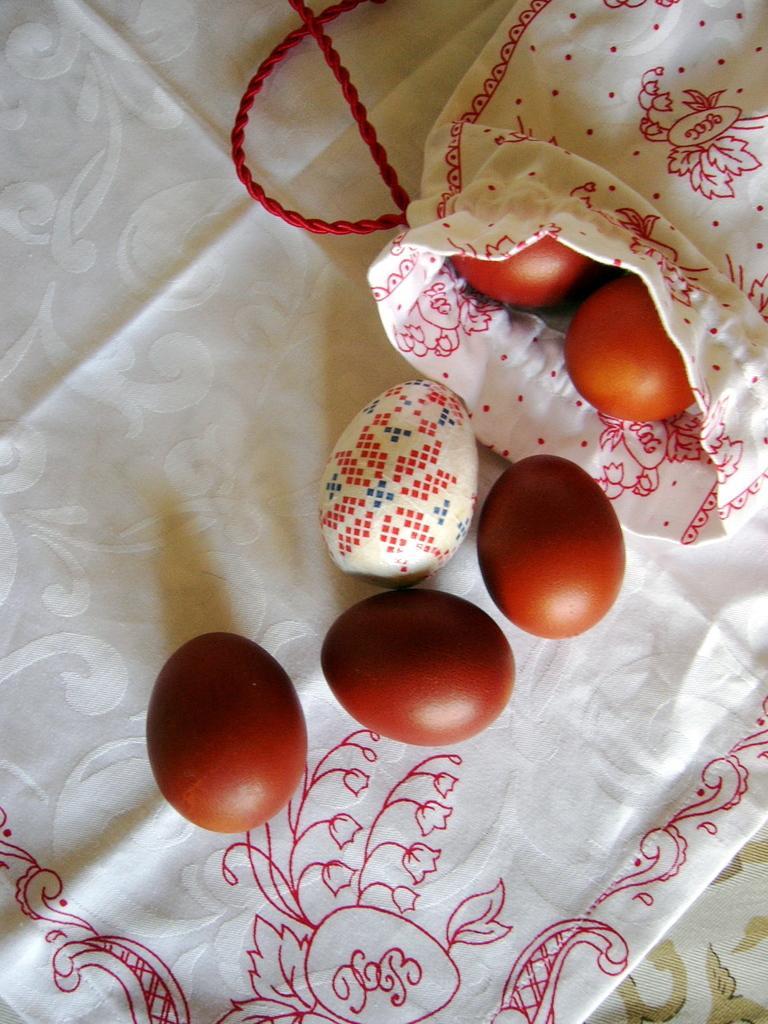How would you summarize this image in a sentence or two? Here in this picture we can see a cloth, on which we can see some eggs present and we can also see a small sack that is filled with eggs over there and we can see a colorful egg also present over there. 